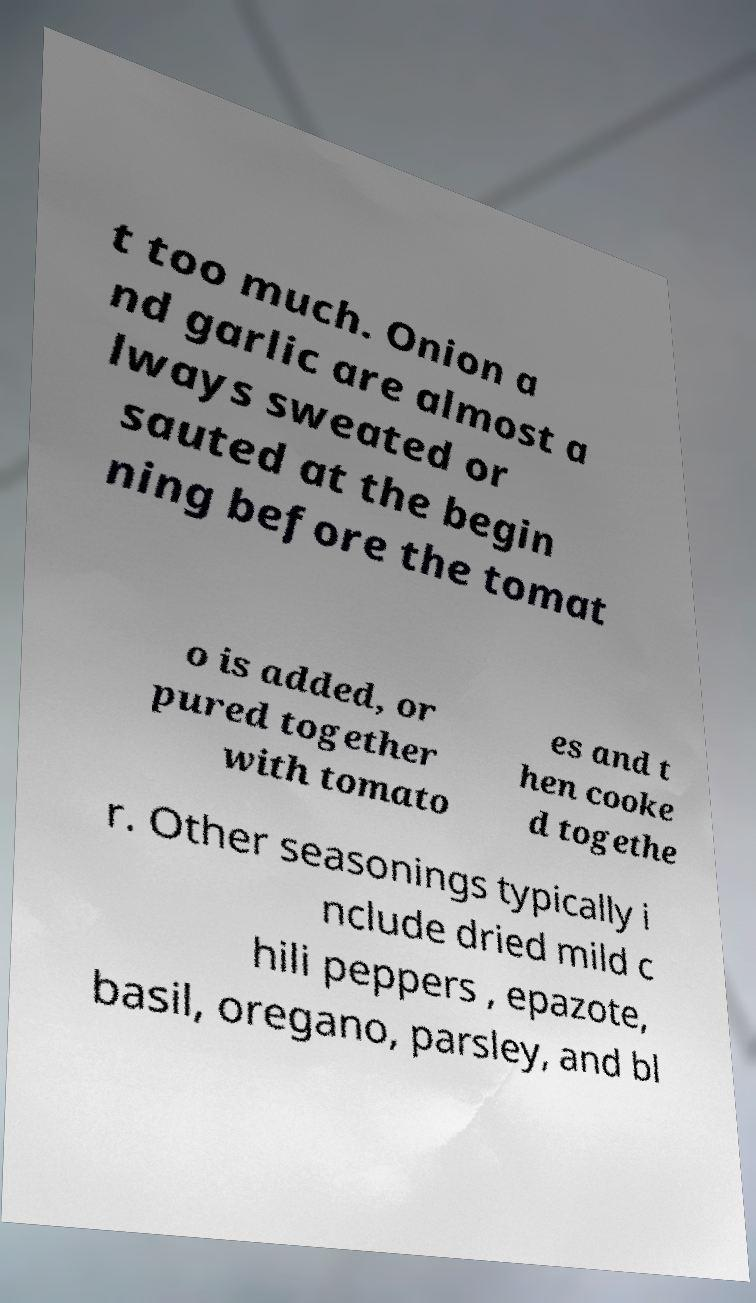I need the written content from this picture converted into text. Can you do that? t too much. Onion a nd garlic are almost a lways sweated or sauted at the begin ning before the tomat o is added, or pured together with tomato es and t hen cooke d togethe r. Other seasonings typically i nclude dried mild c hili peppers , epazote, basil, oregano, parsley, and bl 